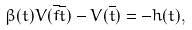<formula> <loc_0><loc_0><loc_500><loc_500>\beta ( t ) V ( \overline { f } \overline { t } ) - V ( \overline { t } ) = - h ( t ) ,</formula> 